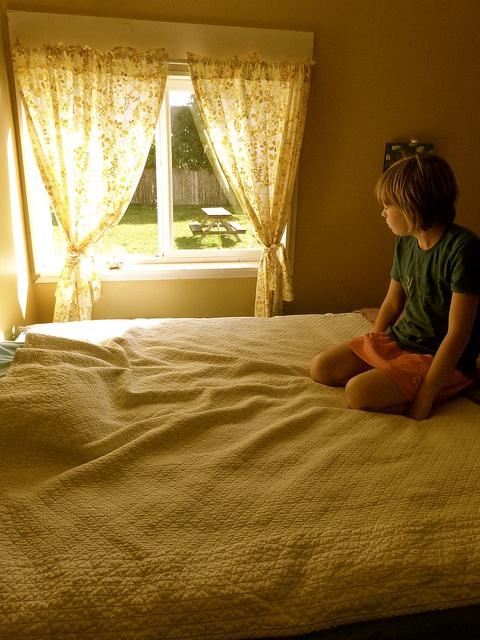Describe the objects in this image and their specific colors. I can see bed in maroon, olive, and tan tones, people in maroon, black, brown, and olive tones, and bench in maroon, tan, white, and olive tones in this image. 